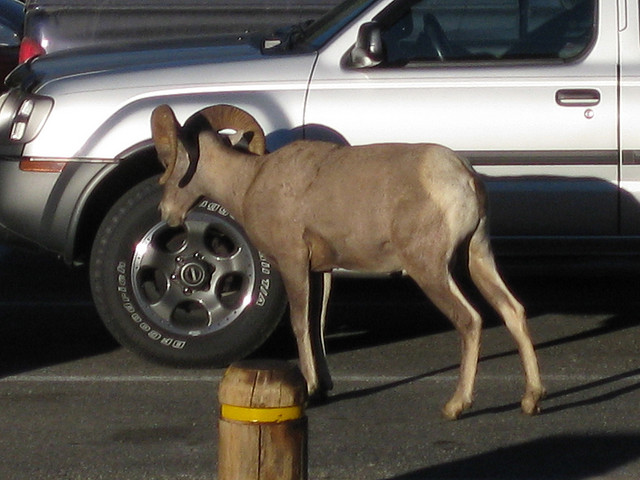What time of day does it seem to be in the photo? Based on the shadows and lighting, it appears to be late afternoon or early evening. 